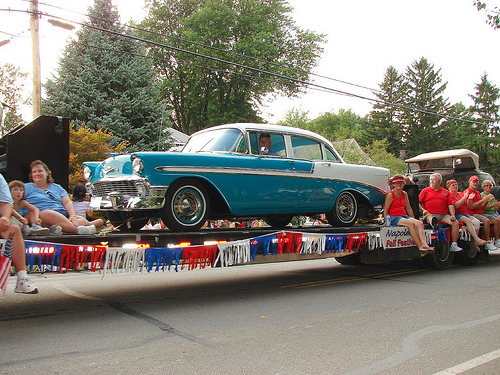<image>
Is there a car above the road? Yes. The car is positioned above the road in the vertical space, higher up in the scene. 